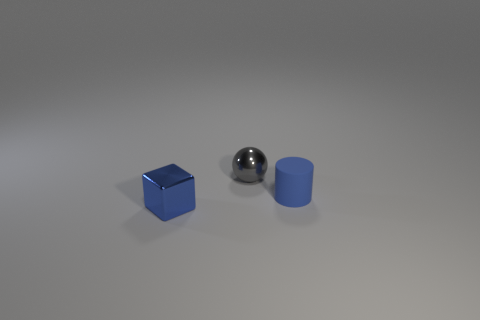How many cyan objects are either tiny shiny objects or large cylinders?
Keep it short and to the point. 0. Is the number of metal cubes behind the matte object less than the number of small blue blocks right of the tiny shiny block?
Your answer should be compact. No. Are there any blue metal cylinders of the same size as the metal sphere?
Your answer should be very brief. No. Is the size of the blue thing that is in front of the blue rubber object the same as the matte cylinder?
Keep it short and to the point. Yes. Are there more gray metal spheres than tiny blue rubber balls?
Ensure brevity in your answer.  Yes. What shape is the blue object to the left of the matte object?
Your response must be concise. Cube. What number of metal spheres are right of the blue thing that is left of the small blue thing that is behind the blue cube?
Offer a very short reply. 1. Does the small object that is to the left of the gray sphere have the same color as the tiny matte cylinder?
Your answer should be compact. Yes. What number of other things are there of the same shape as the tiny gray object?
Provide a short and direct response. 0. How many other things are there of the same material as the small sphere?
Your response must be concise. 1. 